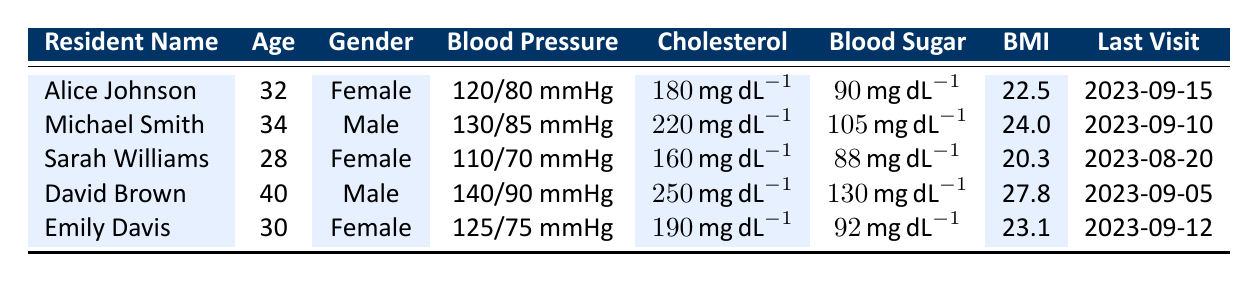What is Alice Johnson's blood pressure? Alice Johnson's blood pressure is listed in the table under the corresponding column, which states "120/80 mmHg."
Answer: 120/80 mmHg How many male residents are in the table? The table has two male residents: Michael Smith and David Brown. By checking the 'Gender' column, we can see that these two names appear with "Male" listed next to them.
Answer: 2 What is the average BMI of the residents in the table? To find the average BMI, we first add all the BMI values: 22.5 + 24.0 + 20.3 + 27.8 + 23.1 = 117.7. Then, dividing by the number of residents (5), we get 117.7 / 5 = 23.54.
Answer: 23.54 Did Emily Davis have a cholesterol level above 200 mg/dL? Looking at the table under the cholesterol column, Emily Davis has a cholesterol level of "190 mg/dL," which is below 200 mg/dL. Therefore, the answer is no.
Answer: No Which resident has the highest blood sugar level? By comparing the blood sugar levels in the table, David Brown has the highest blood sugar at "130 mg/dL," while the others are lower: Alice (90), Michael (105), Sarah (88), and Emily (92).
Answer: David Brown How many residents have a cholesterol level below 200 mg/dL? From the table, Alice Johnson (180), Sarah Williams (160), and Emily Davis (190) have cholesterol levels below 200 mg/dL. That makes it three individuals.
Answer: 3 Is Sarah Williams older than 30 years old? Looking at the 'Age' column, Sarah Williams is recorded to be 28 years old, which means she is not older than 30 years. Thus, the answer is no.
Answer: No What is the blood pressure of Michael Smith? The blood pressure for Michael Smith is found under his name in the "Blood Pressure" column, which shows it as "130/85 mmHg."
Answer: 130/85 mmHg 